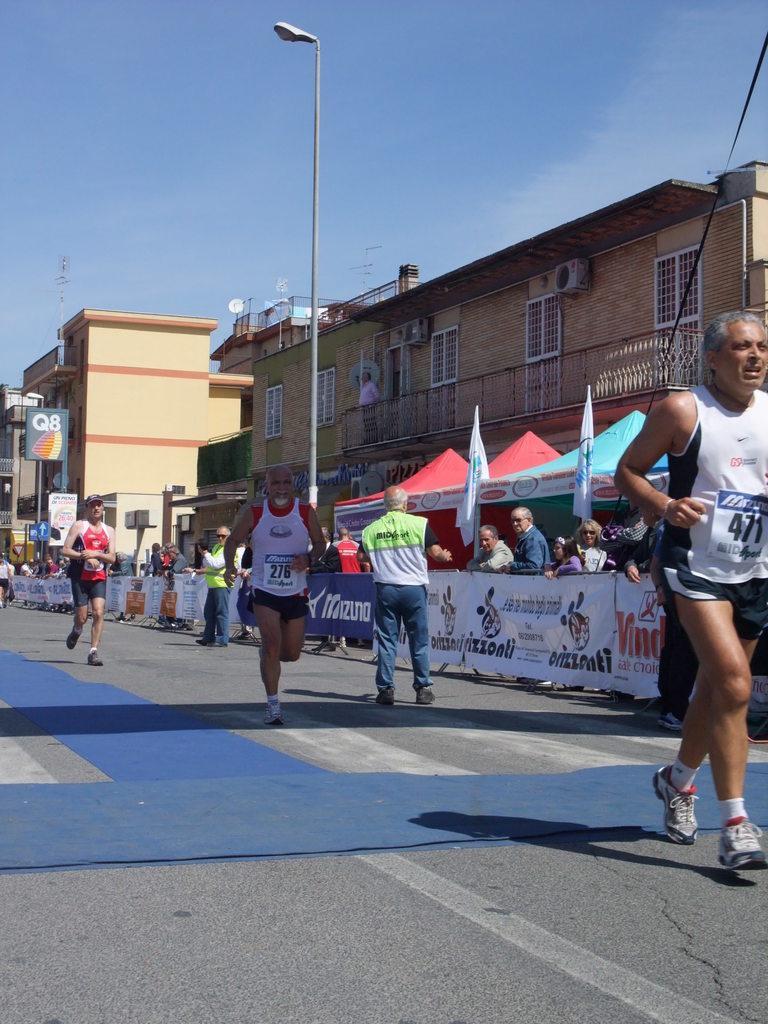Please provide a concise description of this image. On the right there is a man who is wearing white t-shirt and shoe. Here we can see two men who are running on the road. Beside them we can see the security persons was standing near to the banners. In the background we can see buildings, poles, street lights, flags and umbrella. At the top we can see sky, clouds and star. 